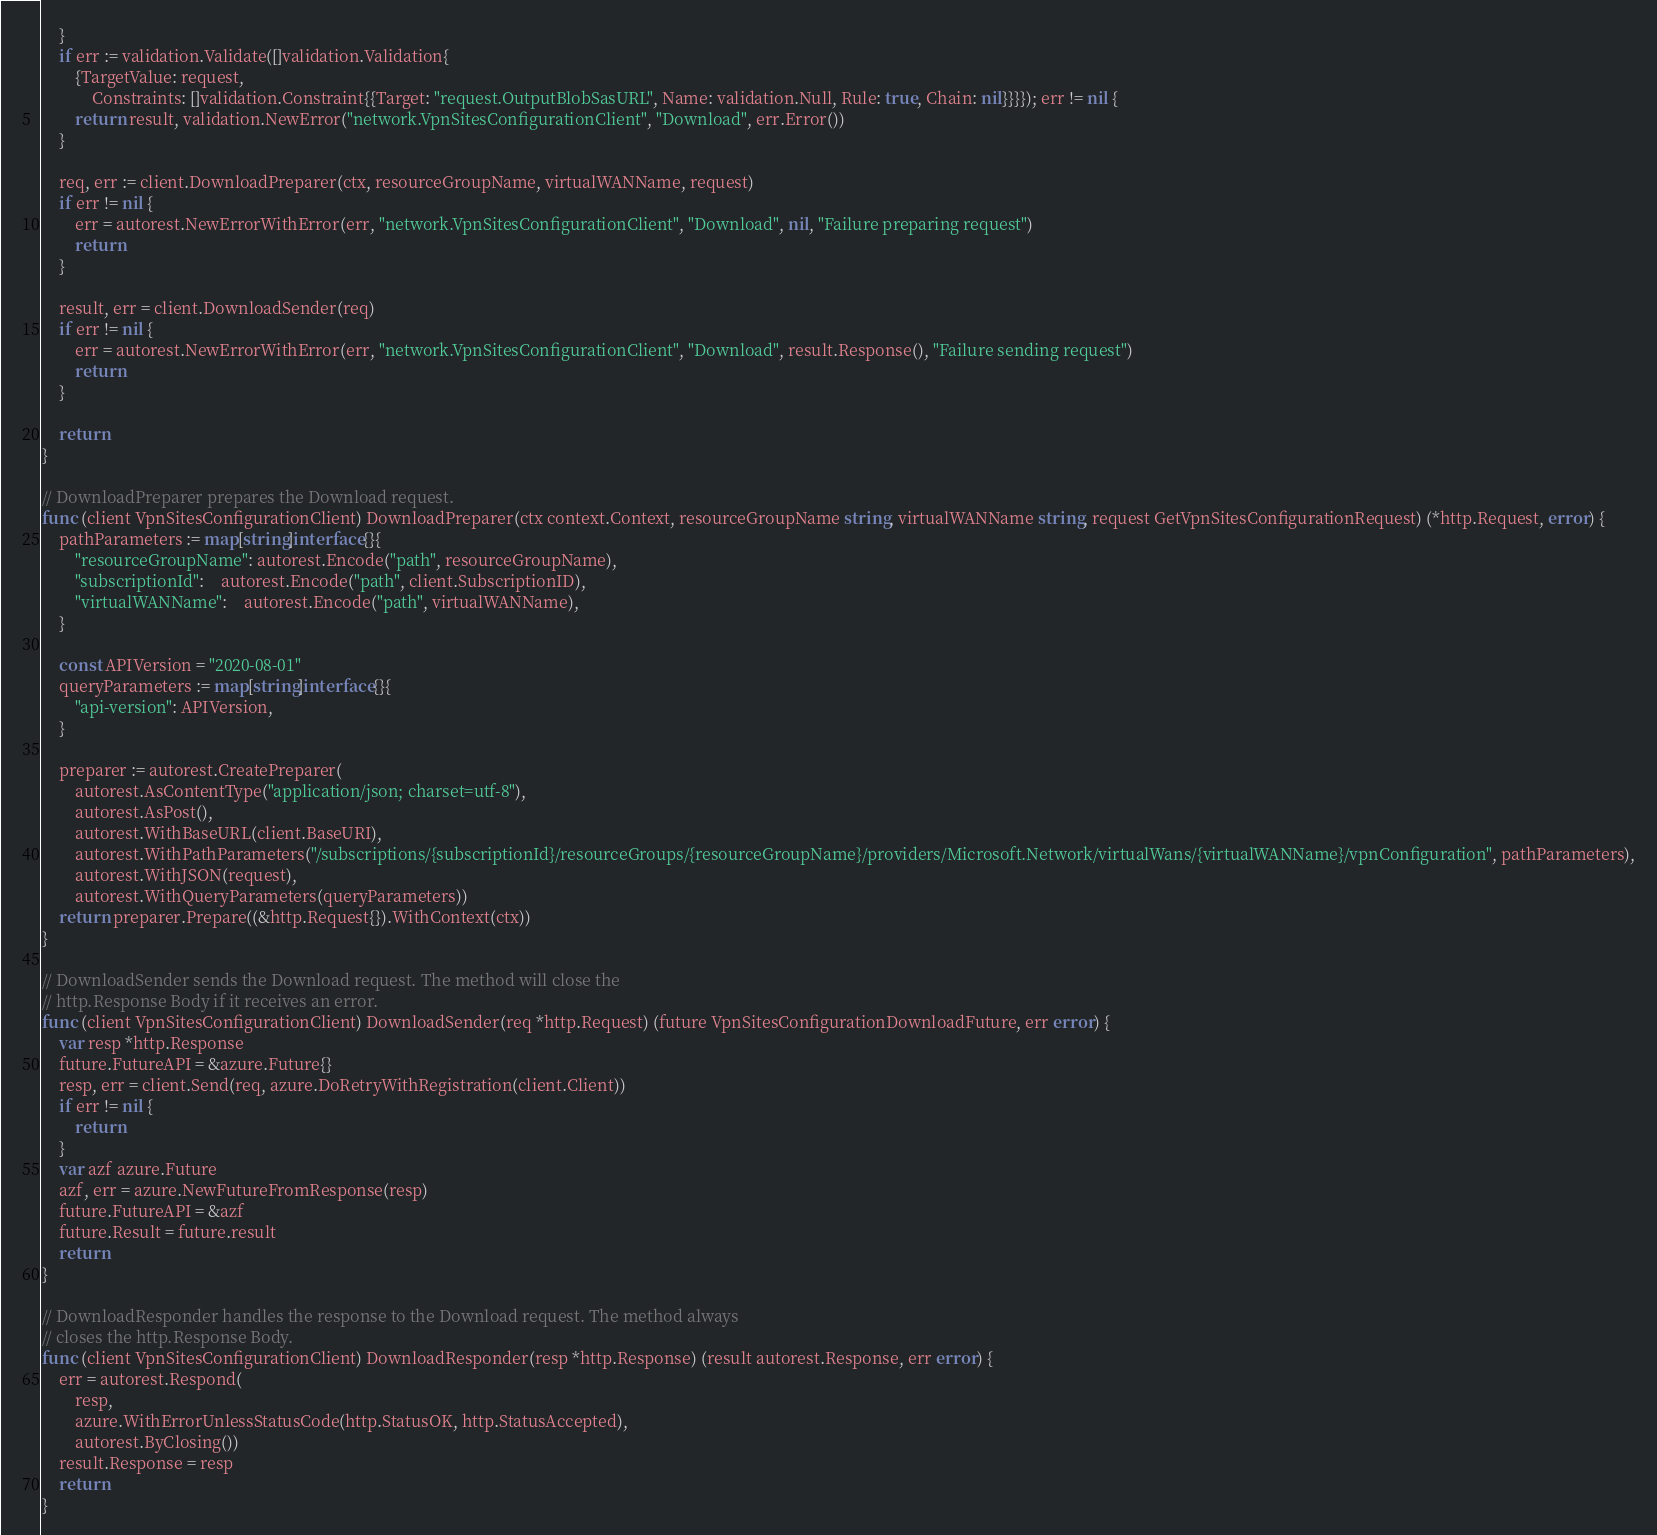<code> <loc_0><loc_0><loc_500><loc_500><_Go_>	}
	if err := validation.Validate([]validation.Validation{
		{TargetValue: request,
			Constraints: []validation.Constraint{{Target: "request.OutputBlobSasURL", Name: validation.Null, Rule: true, Chain: nil}}}}); err != nil {
		return result, validation.NewError("network.VpnSitesConfigurationClient", "Download", err.Error())
	}

	req, err := client.DownloadPreparer(ctx, resourceGroupName, virtualWANName, request)
	if err != nil {
		err = autorest.NewErrorWithError(err, "network.VpnSitesConfigurationClient", "Download", nil, "Failure preparing request")
		return
	}

	result, err = client.DownloadSender(req)
	if err != nil {
		err = autorest.NewErrorWithError(err, "network.VpnSitesConfigurationClient", "Download", result.Response(), "Failure sending request")
		return
	}

	return
}

// DownloadPreparer prepares the Download request.
func (client VpnSitesConfigurationClient) DownloadPreparer(ctx context.Context, resourceGroupName string, virtualWANName string, request GetVpnSitesConfigurationRequest) (*http.Request, error) {
	pathParameters := map[string]interface{}{
		"resourceGroupName": autorest.Encode("path", resourceGroupName),
		"subscriptionId":    autorest.Encode("path", client.SubscriptionID),
		"virtualWANName":    autorest.Encode("path", virtualWANName),
	}

	const APIVersion = "2020-08-01"
	queryParameters := map[string]interface{}{
		"api-version": APIVersion,
	}

	preparer := autorest.CreatePreparer(
		autorest.AsContentType("application/json; charset=utf-8"),
		autorest.AsPost(),
		autorest.WithBaseURL(client.BaseURI),
		autorest.WithPathParameters("/subscriptions/{subscriptionId}/resourceGroups/{resourceGroupName}/providers/Microsoft.Network/virtualWans/{virtualWANName}/vpnConfiguration", pathParameters),
		autorest.WithJSON(request),
		autorest.WithQueryParameters(queryParameters))
	return preparer.Prepare((&http.Request{}).WithContext(ctx))
}

// DownloadSender sends the Download request. The method will close the
// http.Response Body if it receives an error.
func (client VpnSitesConfigurationClient) DownloadSender(req *http.Request) (future VpnSitesConfigurationDownloadFuture, err error) {
	var resp *http.Response
	future.FutureAPI = &azure.Future{}
	resp, err = client.Send(req, azure.DoRetryWithRegistration(client.Client))
	if err != nil {
		return
	}
	var azf azure.Future
	azf, err = azure.NewFutureFromResponse(resp)
	future.FutureAPI = &azf
	future.Result = future.result
	return
}

// DownloadResponder handles the response to the Download request. The method always
// closes the http.Response Body.
func (client VpnSitesConfigurationClient) DownloadResponder(resp *http.Response) (result autorest.Response, err error) {
	err = autorest.Respond(
		resp,
		azure.WithErrorUnlessStatusCode(http.StatusOK, http.StatusAccepted),
		autorest.ByClosing())
	result.Response = resp
	return
}
</code> 